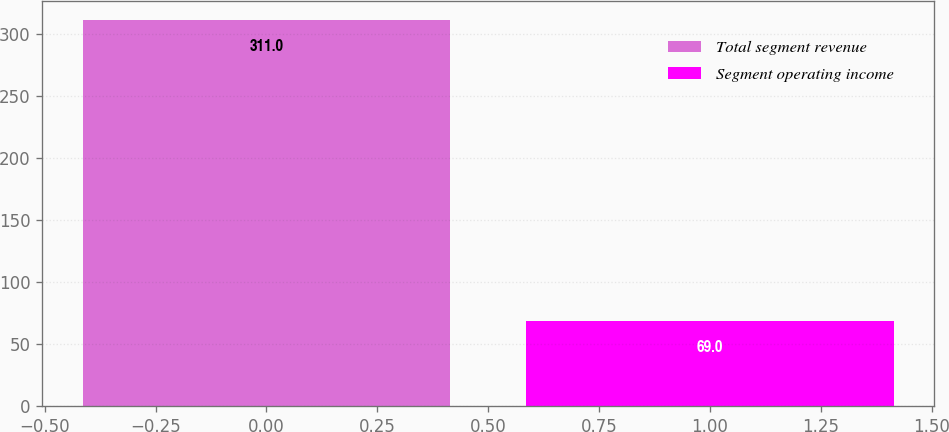Convert chart to OTSL. <chart><loc_0><loc_0><loc_500><loc_500><bar_chart><fcel>Total segment revenue<fcel>Segment operating income<nl><fcel>311<fcel>69<nl></chart> 